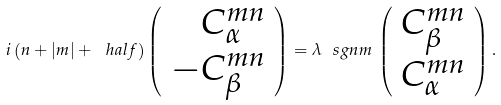Convert formula to latex. <formula><loc_0><loc_0><loc_500><loc_500>i \left ( n + | m | + \ h a l f \right ) \left ( \begin{array} { r } C ^ { m n } _ { \alpha } \\ - C ^ { m n } _ { \beta } \end{array} \right ) = \lambda \ s g n m \, \left ( \begin{array} { c } C ^ { m n } _ { \beta } \\ C ^ { m n } _ { \alpha } \end{array} \right ) .</formula> 